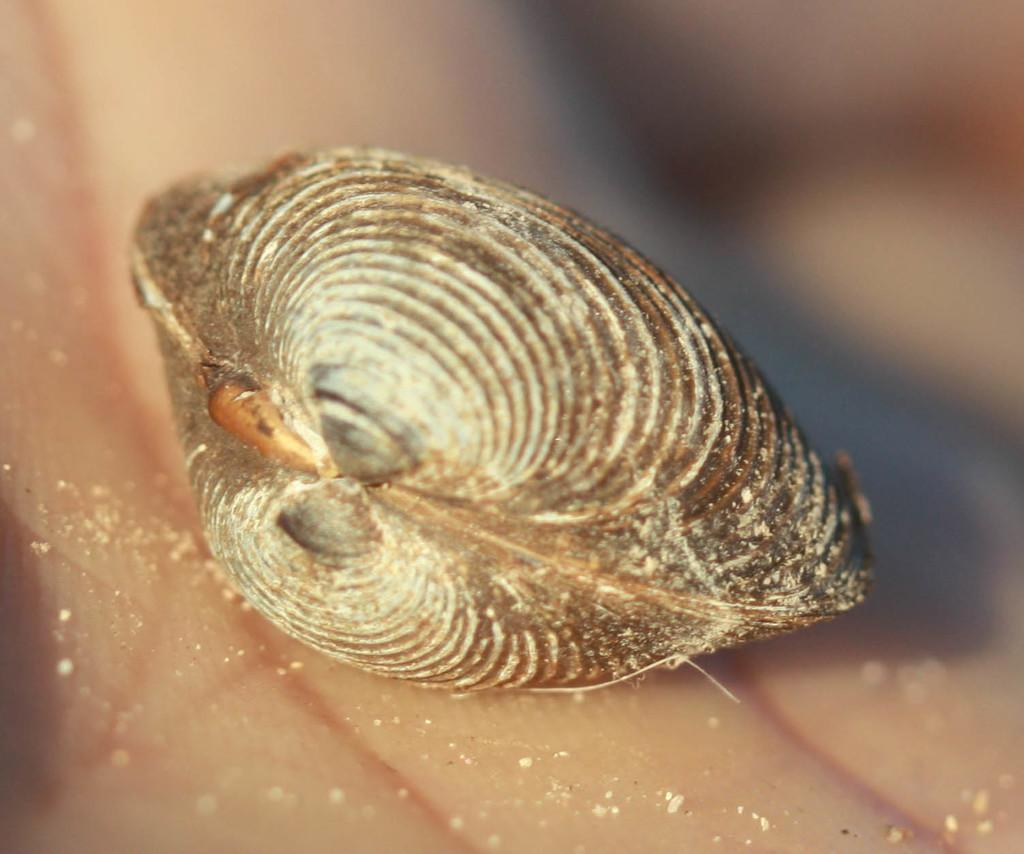What can be seen in the image? There is a person's hand in the image. What is the person holding in their hand? A cockle is present in the hand. Where is the icicle located in the image? There is no icicle present in the image. What type of hall can be seen in the background of the image? There is no hall visible in the image; it only shows a person's hand holding a cockle. 